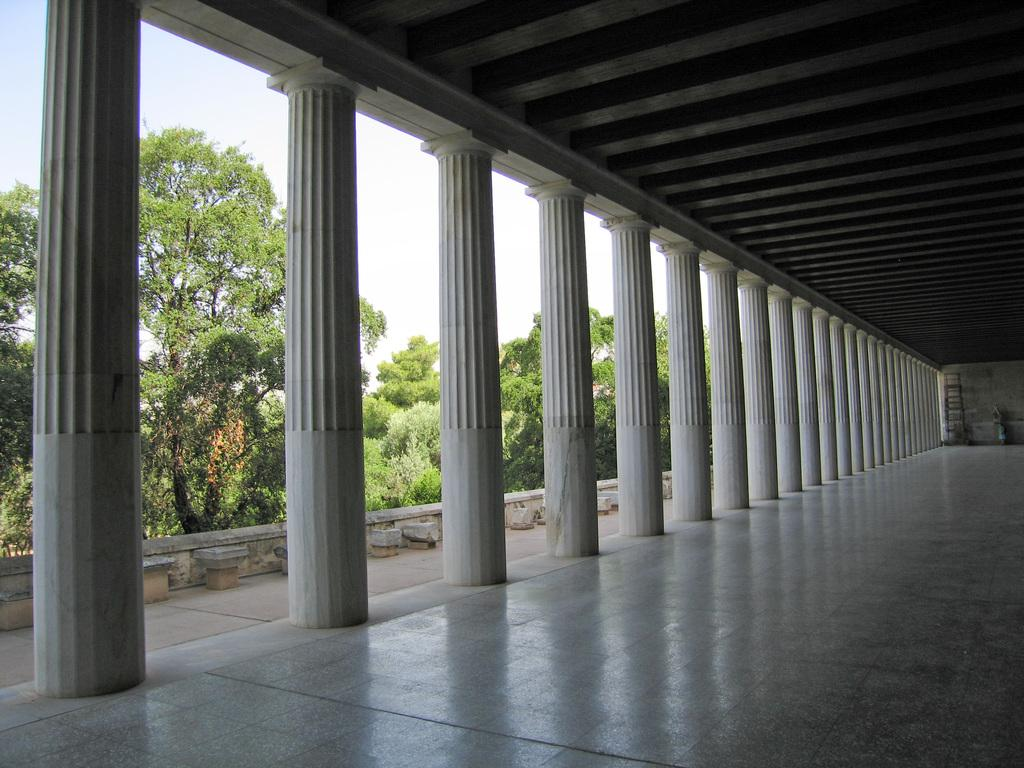What type of structure can be seen in the image? There is a shed in the image. What architectural elements are present in the image? There are pillars in the image. What type of vegetation is visible in the image? There are trees visible in the image. What is visible in the background of the image? The sky is visible in the image. What type of flesh can be seen hanging from the pillars in the image? There is no flesh present in the image; it features a shed, pillars, trees, and the sky. 